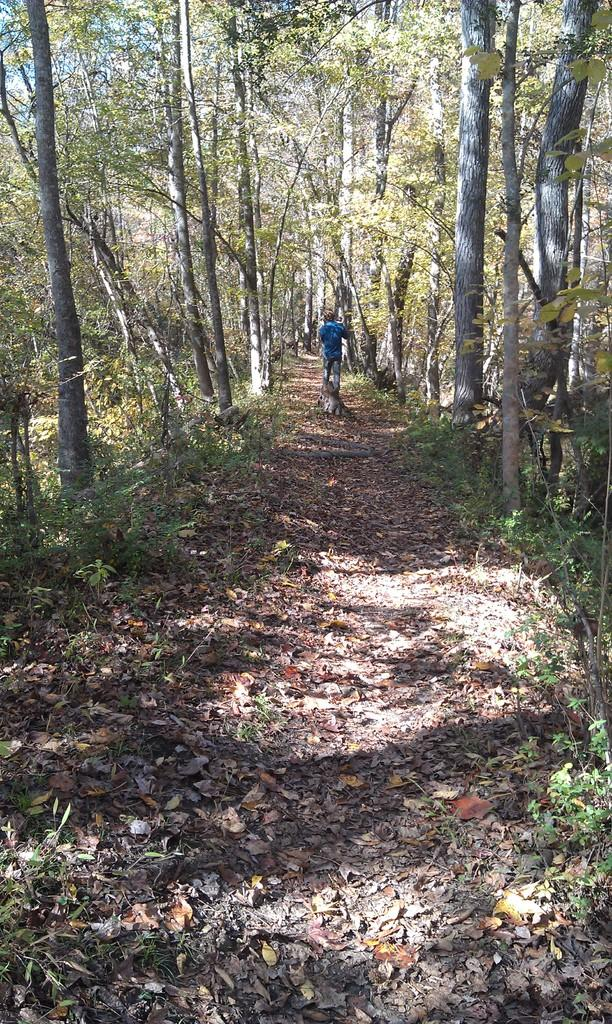Who or what is present in the image? There is a person in the image. What type of natural elements can be seen in the image? There are trees and plants in the image. What is the surface visible in the image? The ground is visible in the image. What is present on the ground in the image? Dried leaves are present on the ground. What type of acoustics can be heard in the office in the image? There is no office present in the image, and therefore no acoustics can be heard. 